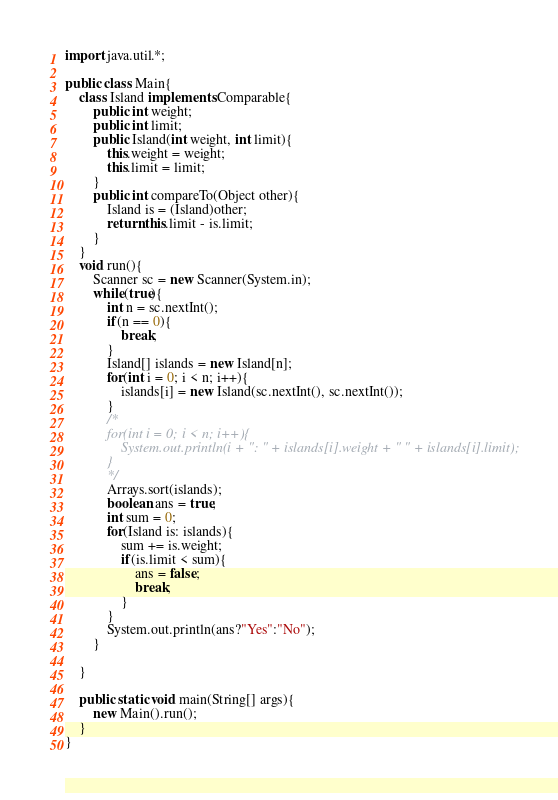Convert code to text. <code><loc_0><loc_0><loc_500><loc_500><_Java_>import java.util.*;

public class Main{
    class Island implements Comparable{
        public int weight;
        public int limit;
        public Island(int weight, int limit){
            this.weight = weight;
            this.limit = limit;
        }
        public int compareTo(Object other){
            Island is = (Island)other;
            return this.limit - is.limit;
        }
    }
    void run(){
        Scanner sc = new Scanner(System.in);
        while(true){
            int n = sc.nextInt();
            if(n == 0){
                break;
            }
            Island[] islands = new Island[n];
            for(int i = 0; i < n; i++){
                islands[i] = new Island(sc.nextInt(), sc.nextInt());
            }
            /*
            for(int i = 0; i < n; i++){
                System.out.println(i + ": " + islands[i].weight + " " + islands[i].limit);
            }
            */
            Arrays.sort(islands);
            boolean ans = true;
            int sum = 0;
            for(Island is: islands){
                sum += is.weight;
                if(is.limit < sum){
                    ans = false;
                    break;
                }
            }
            System.out.println(ans?"Yes":"No");
        }
        
    }

    public static void main(String[] args){
        new Main().run();
    }
}</code> 